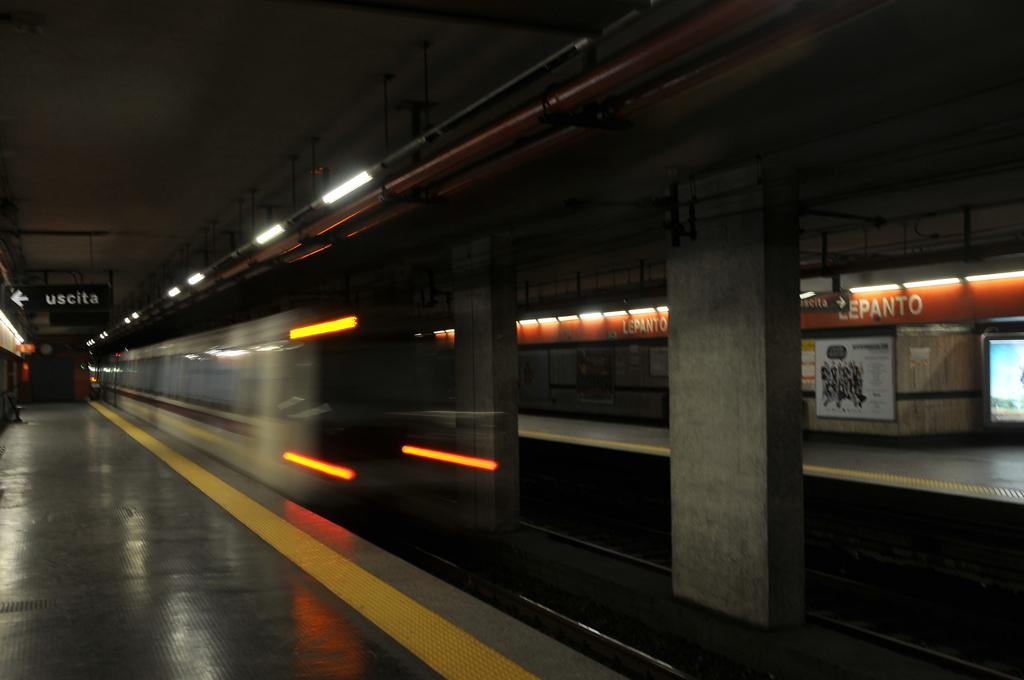What type of structure is shown in the image? There is a railway station in the image. How many platforms are present at the railway station? There are two platforms at the railway station. What architectural features can be seen in the image? There are pillars visible in the image. What is located on the railway track in the image? There is a train on the railway track. What type of lighting is present in the image? There are tube lights in the image. What type of celery is being used as a decoration on the train in the image? There is no celery present in the image, and it is not being used as a decoration on the train. What type of zinc is visible on the platforms in the image? There is no zinc visible on the platforms in the image. 